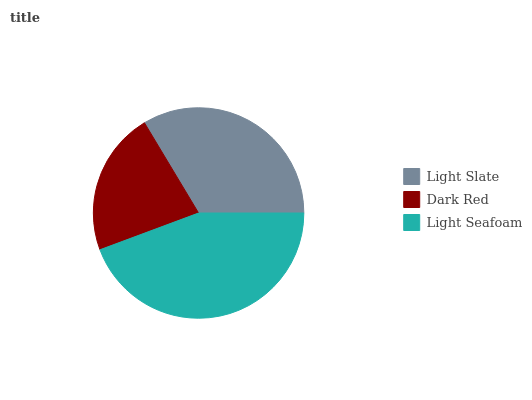Is Dark Red the minimum?
Answer yes or no. Yes. Is Light Seafoam the maximum?
Answer yes or no. Yes. Is Light Seafoam the minimum?
Answer yes or no. No. Is Dark Red the maximum?
Answer yes or no. No. Is Light Seafoam greater than Dark Red?
Answer yes or no. Yes. Is Dark Red less than Light Seafoam?
Answer yes or no. Yes. Is Dark Red greater than Light Seafoam?
Answer yes or no. No. Is Light Seafoam less than Dark Red?
Answer yes or no. No. Is Light Slate the high median?
Answer yes or no. Yes. Is Light Slate the low median?
Answer yes or no. Yes. Is Dark Red the high median?
Answer yes or no. No. Is Dark Red the low median?
Answer yes or no. No. 